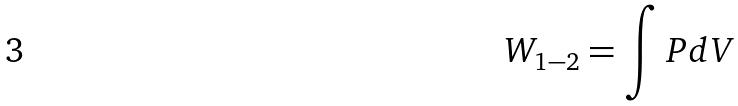Convert formula to latex. <formula><loc_0><loc_0><loc_500><loc_500>W _ { 1 - 2 } = \int P d V</formula> 